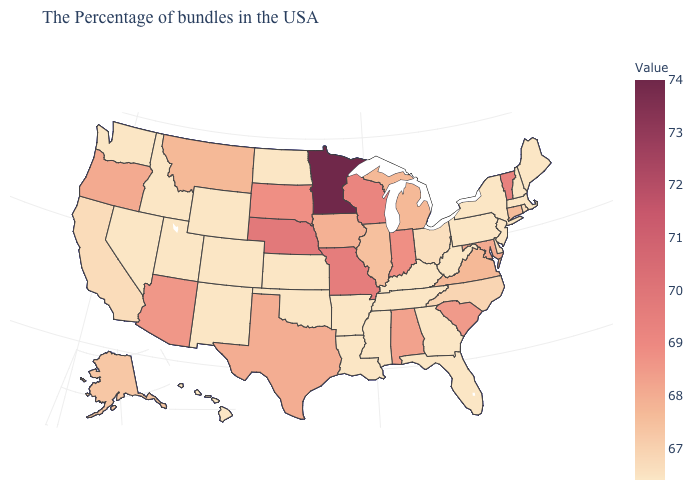Among the states that border New York , which have the highest value?
Concise answer only. Vermont. Among the states that border Rhode Island , does Connecticut have the lowest value?
Concise answer only. No. Which states have the lowest value in the USA?
Be succinct. Maine, Massachusetts, New Hampshire, New York, New Jersey, Pennsylvania, West Virginia, Florida, Georgia, Kentucky, Tennessee, Mississippi, Louisiana, Arkansas, Kansas, Oklahoma, North Dakota, Wyoming, Colorado, New Mexico, Utah, Idaho, Nevada, Washington, Hawaii. Does Minnesota have the highest value in the MidWest?
Short answer required. Yes. Does South Carolina have the highest value in the South?
Short answer required. Yes. Among the states that border Iowa , which have the lowest value?
Quick response, please. Illinois. 